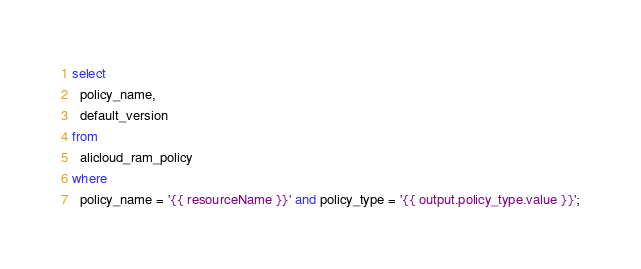Convert code to text. <code><loc_0><loc_0><loc_500><loc_500><_SQL_>select
  policy_name,
  default_version
from
  alicloud_ram_policy
where
  policy_name = '{{ resourceName }}' and policy_type = '{{ output.policy_type.value }}';</code> 